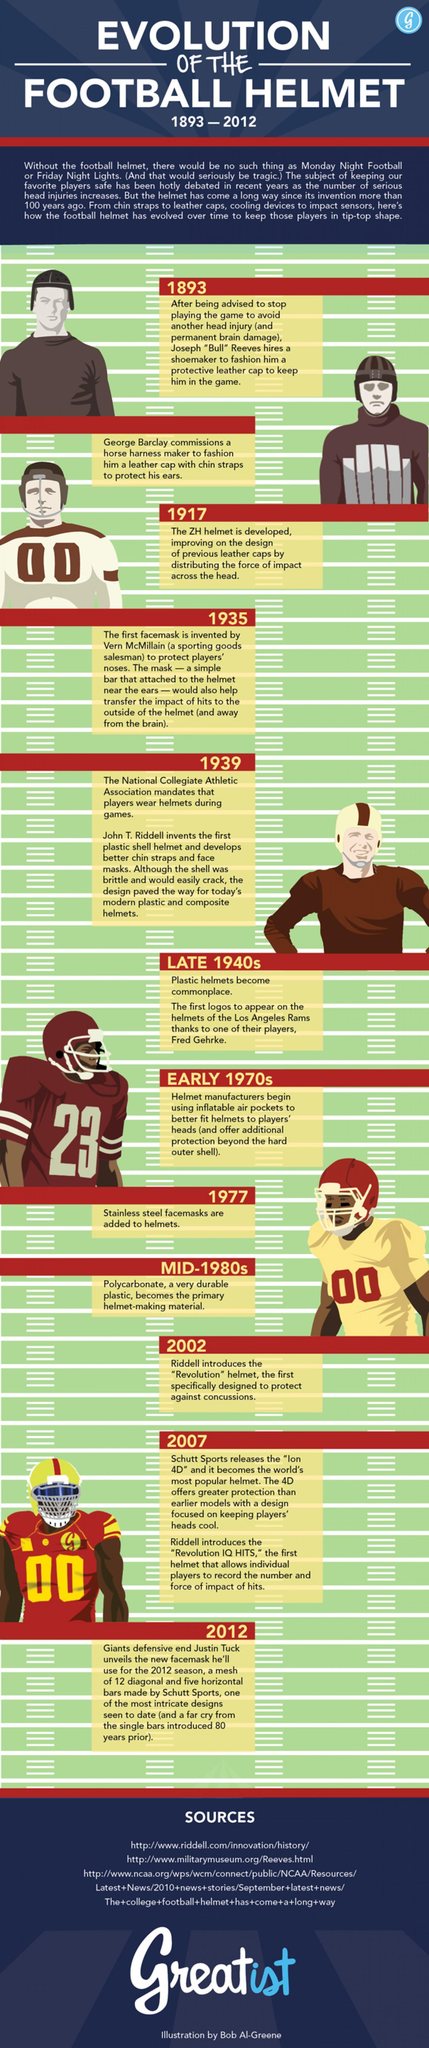How many sources are listed at the bottom?
Answer the question with a short phrase. 3 